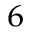<formula> <loc_0><loc_0><loc_500><loc_500>_ { 6 }</formula> 